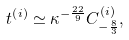<formula> <loc_0><loc_0><loc_500><loc_500>t ^ { \left ( i \right ) } \simeq \kappa ^ { - \frac { 2 2 } { 9 } } C ^ { \left ( i \right ) } _ { - \frac { 8 } { 3 } } ,</formula> 